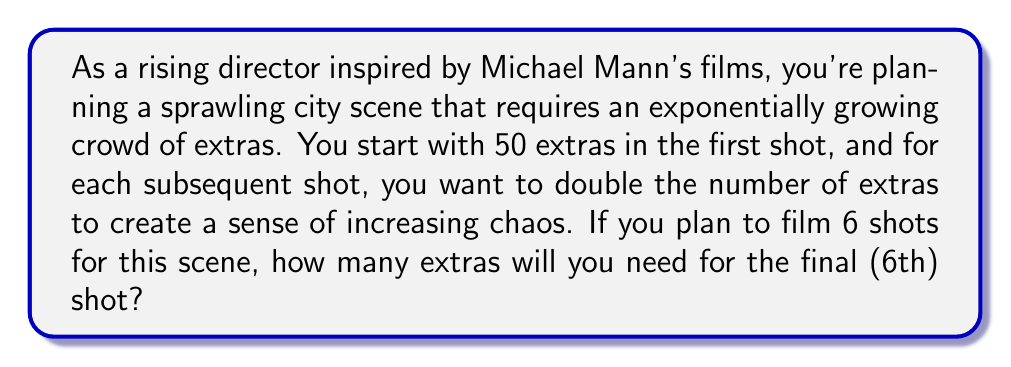Can you answer this question? Let's approach this step-by-step using the concept of exponential growth:

1) We start with 50 extras in the first shot.
2) The number of extras doubles with each shot, which means we're dealing with exponential growth with a base of 2.
3) We can represent this mathematically as:

   $N = 50 \cdot 2^{(n-1)}$

   Where $N$ is the number of extras, and $n$ is the shot number.

4) We want to know the number of extras for the 6th shot, so we plug in $n = 6$:

   $N = 50 \cdot 2^{(6-1)} = 50 \cdot 2^5$

5) Now let's calculate:
   
   $50 \cdot 2^5 = 50 \cdot 32 = 1600$

Therefore, for the 6th and final shot, you will need 1600 extras.

To visualize the growth:

Shot 1: 50 extras
Shot 2: 100 extras
Shot 3: 200 extras
Shot 4: 400 extras
Shot 5: 800 extras
Shot 6: 1600 extras

This exponential growth mimics the increasing intensity often seen in Michael Mann's films, where tension builds rapidly towards a climax.
Answer: 1600 extras 